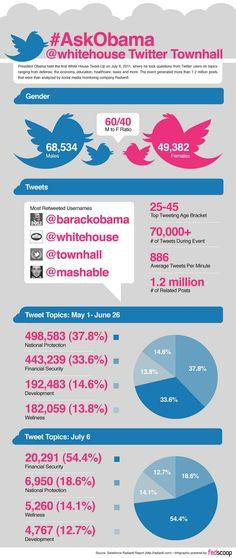Specify some key components in this picture. In July, the topic that was most frequently tweeted was financial security. There were 182,059 tweets about wellness from May 1st to June 30th. The most tweeted topic from May 1 to June 30 moved to the second position in July. 